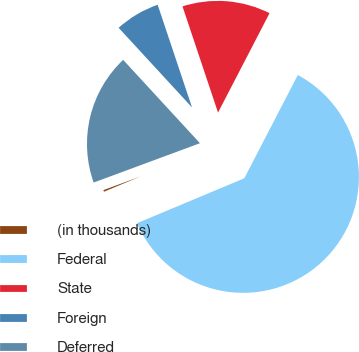Convert chart to OTSL. <chart><loc_0><loc_0><loc_500><loc_500><pie_chart><fcel>(in thousands)<fcel>Federal<fcel>State<fcel>Foreign<fcel>Deferred<nl><fcel>0.67%<fcel>61.08%<fcel>12.75%<fcel>6.71%<fcel>18.79%<nl></chart> 